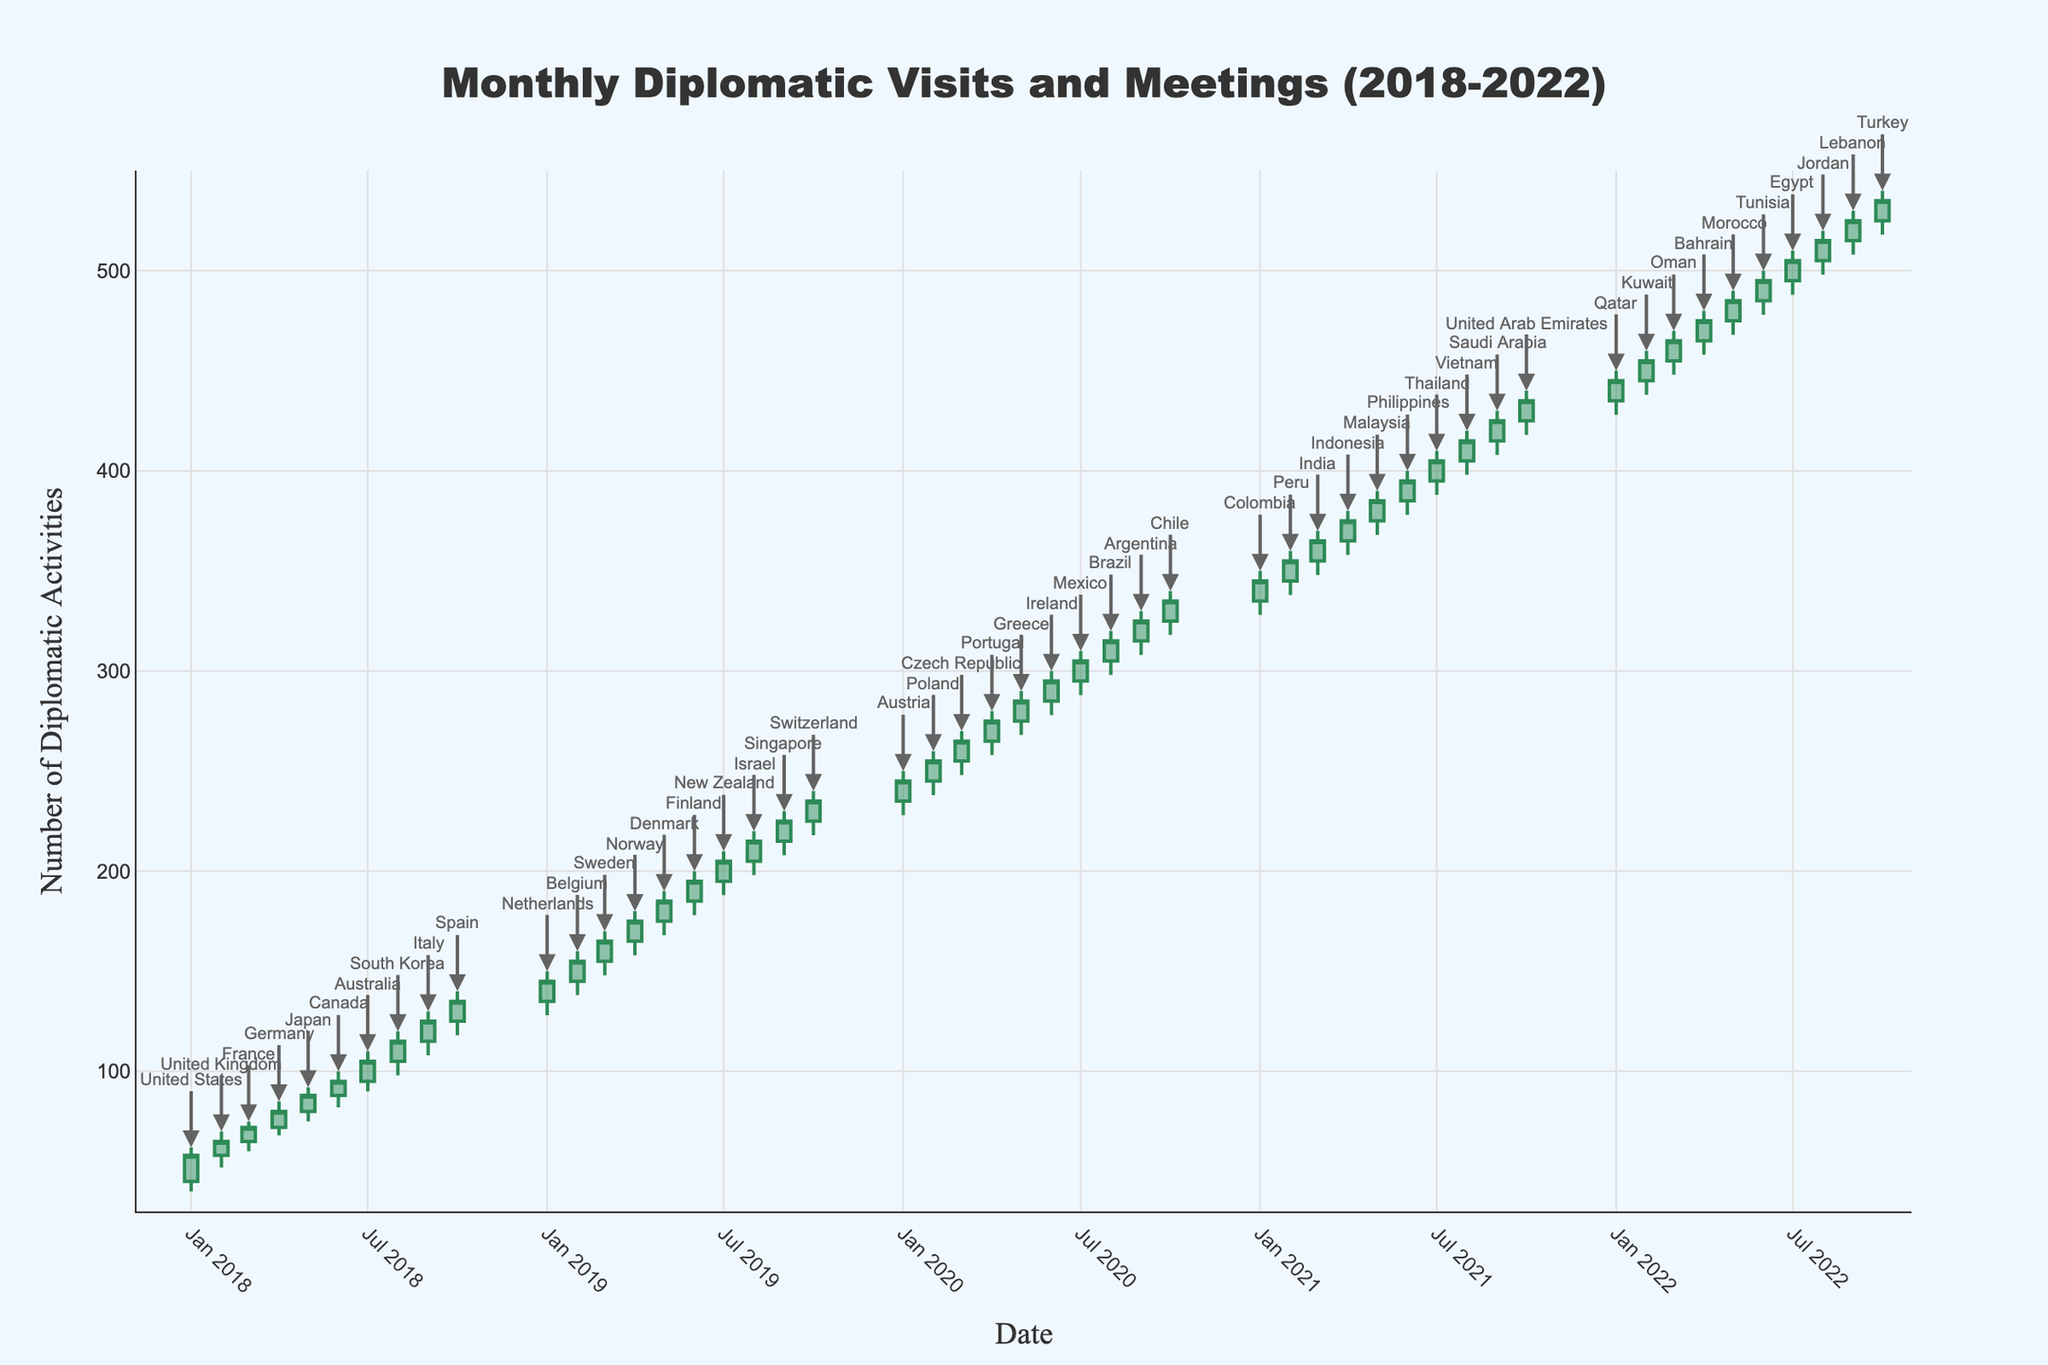What is the title of the figure? The title of a figure is usually prominently displayed at the top of the chart. In this case, it is 'Monthly Diplomatic Visits and Meetings (2018-2022)', indicating the subject and the timeframe of the data.
Answer: Monthly Diplomatic Visits and Meetings (2018-2022) Which month and year had the highest number of diplomatic activities? To find the month and year with the highest number, you look for the data point with the highest "High" value. From the figure data, it is in 2022-09, corresponding to 530 diplomatic activities in September 2022.
Answer: September 2022 On average, how many diplomatic activities were reported in the most active year? The most active year can be calculated by summing up all 'Close' values of that year and dividing by the number of months. For 2021, sum of Close values: 345 + 355 + 365 + 375 + 385 + 395 + 405 + 415 + 425 + 435 = 3900. Number of months: 10. Thus, the average is 3900/10.
Answer: 390 Which two countries experienced the largest and smallest swing in diplomatic activities in 2020? Calculate the difference between the 'High' and 'Low' values for each month in 2020 and compare. The largest swing is observed in January (250 - 228 = 22) with Austria, and the smallest in July (310 - 288 = 22) with Mexico.
Answer: Austria & Mexico How many countries had a 'High' value greater than or equal to 300 in 2020? By examining each 'High' value for 2020 and counting those greater than or equal to 300, you find April (280), May (290), June (300), July (310), August (320), September (330), and October (340). Thus, there are 7 instances.
Answer: 7 By how much did the number of diplomatic activities increase in Germany from the start to the end of its peak month? Looking at Germany's data in 2018-04, the activities started at 72 and closed at 80. The increase is the difference between these numbers.
Answer: 8 Which country had the highest opening number of diplomatic activities in 2019? To find the country with the highest 'Open' value in 2019, compare the 'Open' values for each month. In July 2019, New Zealand had the highest opening number with 195.
Answer: New Zealand 